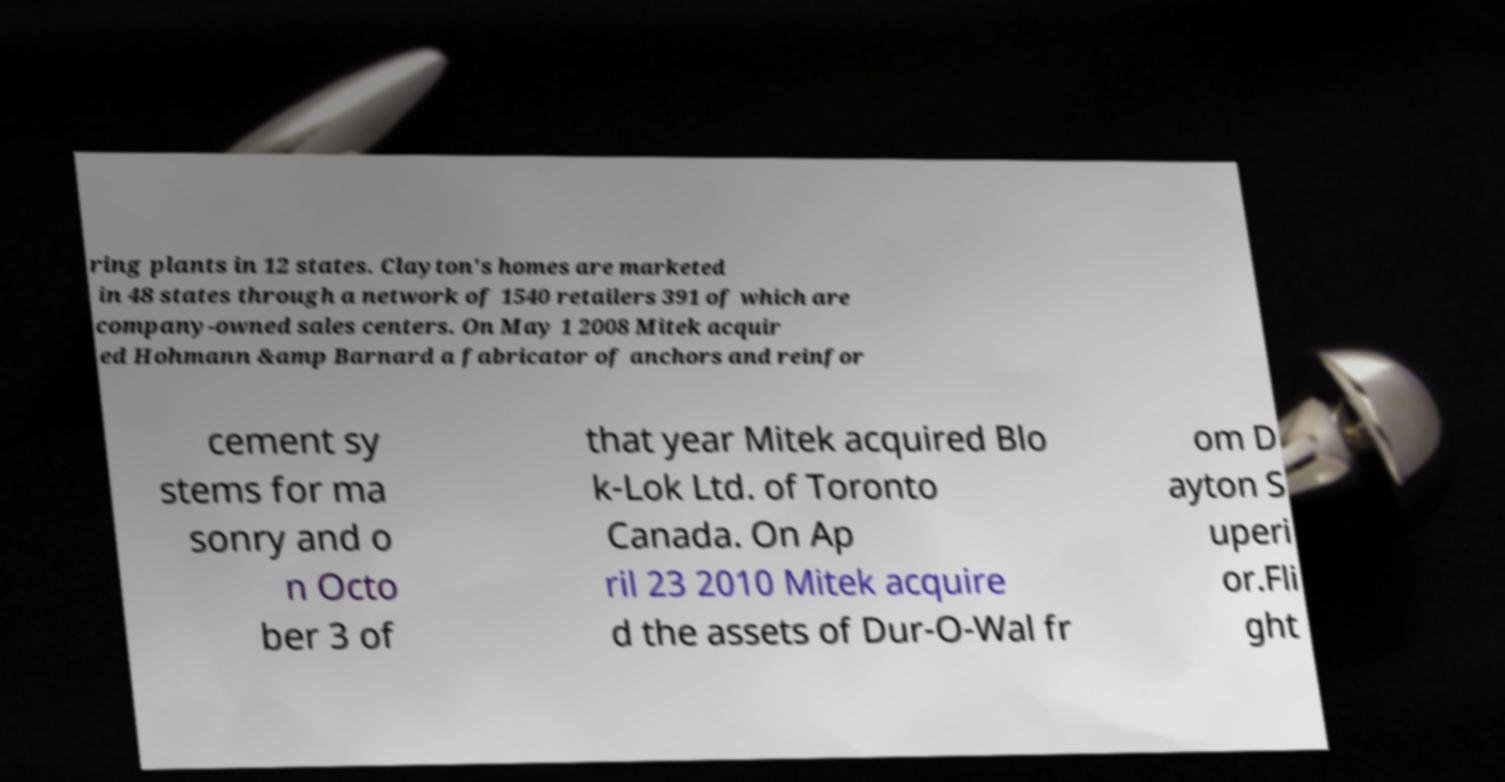Please read and relay the text visible in this image. What does it say? ring plants in 12 states. Clayton's homes are marketed in 48 states through a network of 1540 retailers 391 of which are company-owned sales centers. On May 1 2008 Mitek acquir ed Hohmann &amp Barnard a fabricator of anchors and reinfor cement sy stems for ma sonry and o n Octo ber 3 of that year Mitek acquired Blo k-Lok Ltd. of Toronto Canada. On Ap ril 23 2010 Mitek acquire d the assets of Dur-O-Wal fr om D ayton S uperi or.Fli ght 